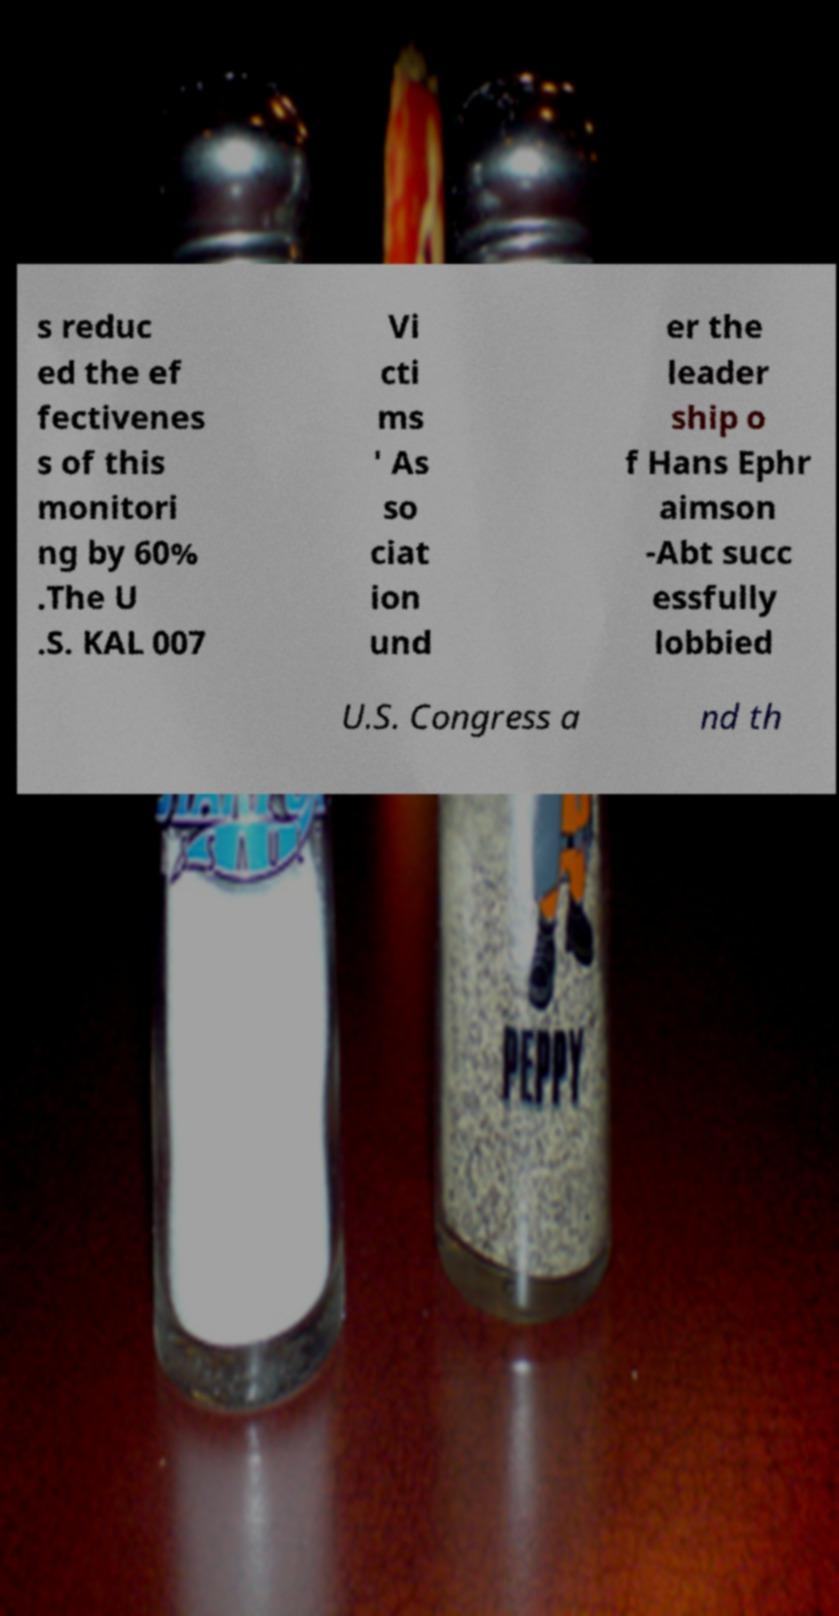I need the written content from this picture converted into text. Can you do that? s reduc ed the ef fectivenes s of this monitori ng by 60% .The U .S. KAL 007 Vi cti ms ' As so ciat ion und er the leader ship o f Hans Ephr aimson -Abt succ essfully lobbied U.S. Congress a nd th 